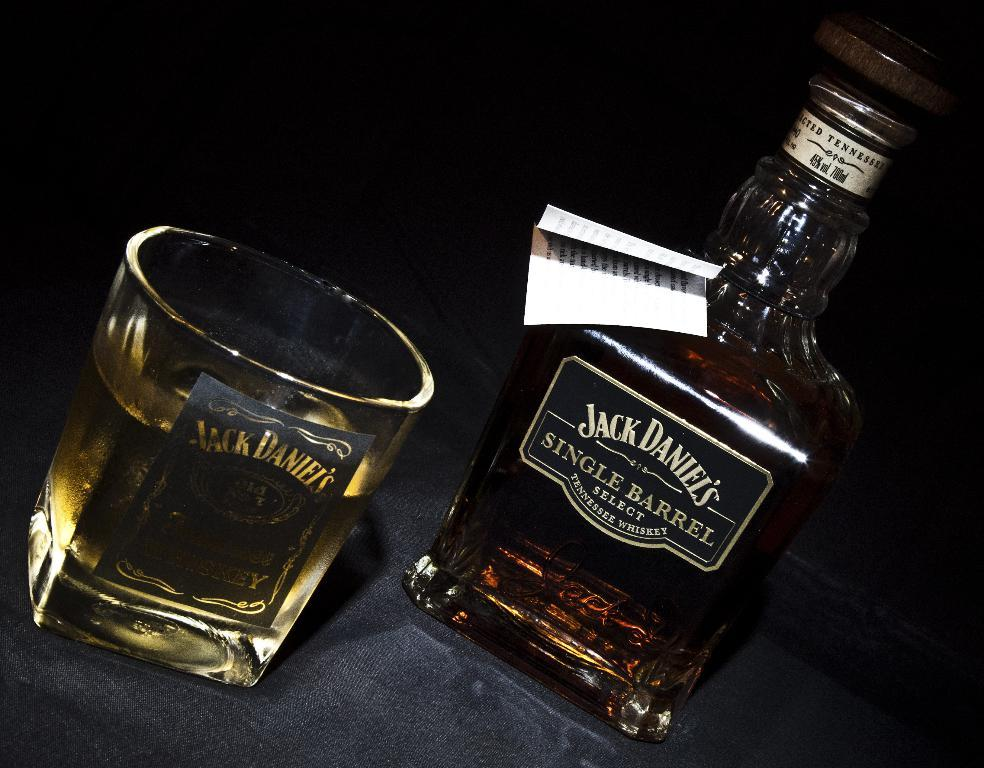<image>
Summarize the visual content of the image. A Jack Daniel's glass is filled with whiskey and sits next to a bottle Jack Daniel's Single Barrel Select Tennessee Whiskey. 